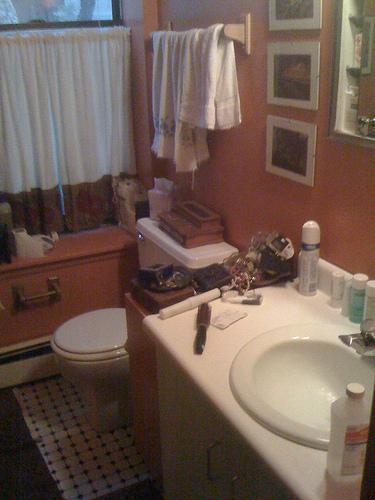How many toilets are there?
Give a very brief answer. 1. How many pictures are there?
Give a very brief answer. 3. 